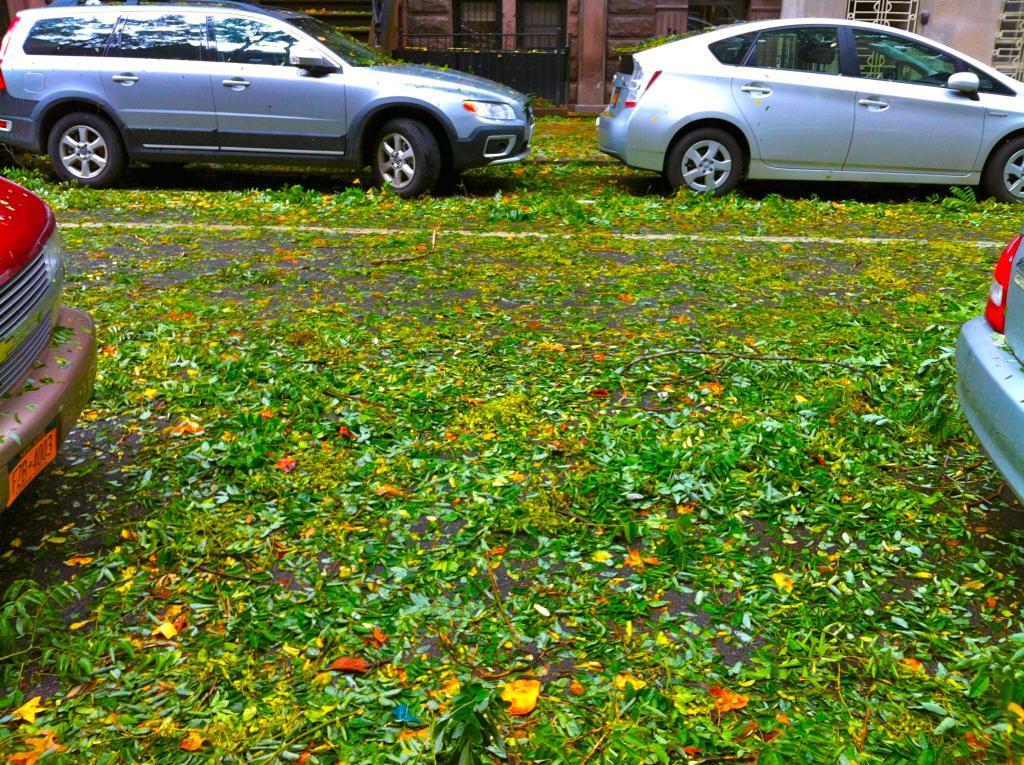Can you describe this image briefly? In this image, we can see some leaves and cars on the road. 